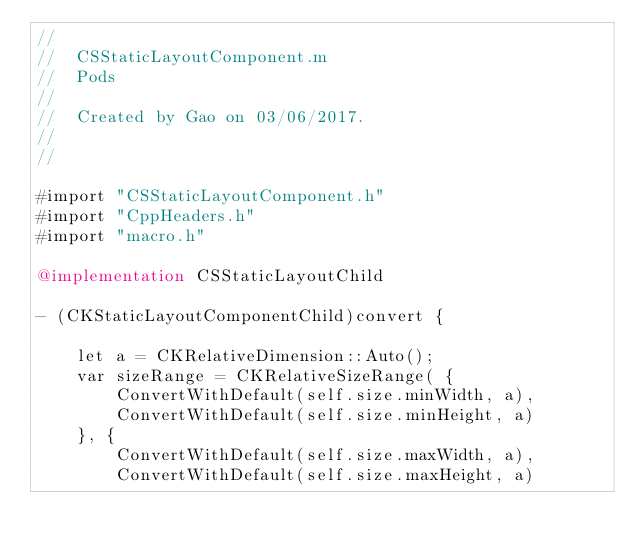<code> <loc_0><loc_0><loc_500><loc_500><_ObjectiveC_>//
//  CSStaticLayoutComponent.m
//  Pods
//
//  Created by Gao on 03/06/2017.
//
//

#import "CSStaticLayoutComponent.h"
#import "CppHeaders.h"
#import "macro.h"

@implementation CSStaticLayoutChild

- (CKStaticLayoutComponentChild)convert {

    let a = CKRelativeDimension::Auto();
    var sizeRange = CKRelativeSizeRange( {
        ConvertWithDefault(self.size.minWidth, a),
        ConvertWithDefault(self.size.minHeight, a)
    }, {
        ConvertWithDefault(self.size.maxWidth, a),
        ConvertWithDefault(self.size.maxHeight, a)</code> 